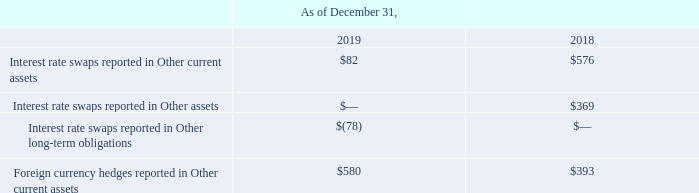NOTES TO CONSOLIDATED FINANCIAL STATEMENTS (in thousands, except for share and per share data)
NOTE 13 — Derivatives
Our earnings and cash flows are subject to fluctuations due to changes in foreign currency exchange rates and interest rates. We selectively use derivative financial instruments including foreign currency forward contracts and interest rate swaps to manage our exposure to these risks.
The use of derivative financial instruments exposes the Company to credit risk, which relates to the risk of nonperformance by a counterparty to the derivative contracts. We manage our credit risk by entering into derivative contracts with only highly rated financial institutions and by using netting agreements.
The effective portion of derivative gains and losses are recorded in accumulated other comprehensive loss until the hedged transaction affects earnings upon settlement, at which time they are reclassified to cost of goods sold or net sales. If it is probable that an anticipated hedged transaction will not occur by the end of the originally specified time period, we reclassify the gains or losses related to that hedge from accumulated other comprehensive loss to other income (expense).
We assess hedge effectiveness qualitatively by verifying that the critical terms of the hedging instrument and the forecasted transaction continue to match, and that there have been no adverse developments that have increased the risk that the counterparty will default. No recognition of ineffectiveness was recorded in our Consolidated Statement of Earnings for the twelve months ended December 31, 2019.
Foreign Currency Hedges
We use forward contracts to mitigate currency risk related to a portion of our forecasted foreign currency revenues and costs. The currency forward contracts are designed as cash flow hedges and are recorded in the Consolidated Balance Sheets at fair value.
We continue to monitor the Company’s overall currency exposure and may elect to add cash flow hedges in the future. At December 31, 2019, we had a net unrealized gain of $655 in accumulated other comprehensive loss, of which $595 is expected to be reclassified to income within the next 12 months. The notional amount of foreign currency forward contracts outstanding was $8,011 at December 31, 2019.
Interest Rate Swaps
We use interest rate swaps to convert a portion of our revolving credit facility's outstanding balance from a variable rate of interest to a fixed rate. As of December 31, 2019, we have agreements to fix interest rates on $50,000 of long-term debt through February 2024. The difference to be paid or received under the terms of the swap agreements will be recognized as an adjustment to interest expense when settled.
These swaps are treated as cash flow hedges and consequently, the changes in fair value are recorded in other comprehensive loss. The estimated net amount of the existing gains or losses that are reported in accumulated other comprehensive loss that are expected to be reclassified into earnings within the next twelve months is approximately $82.
The location and fair values of derivative instruments designated as hedging instruments in the Consolidated Balance Sheets as of December 31, 2019, are shown in the following table:
The Company has elected to net its foreign currency derivative assets and liabilities in the balance sheet in accordance with ASC 210-20 (Balance Sheet, Offsetting). On a gross basis, there were foreign currency derivative assets of $648 and foreign currency derivative liabilities of $68 at December 31, 2019.
Which years does the table provide information for the location and fair values of derivative instruments designated as hedging instruments? 2019, 2018. What were the Interest rate swaps reported in Other assets in 2018?
Answer scale should be: thousand. 369. What was the Foreign currency hedges reported in Other current assets in 2019?
Answer scale should be: thousand. 580. How many years did Foreign currency hedges reported in Other current assets exceed $500 thousand?
Answer scale should be: thousand. 2019
Answer: 1. What was the change in the Interest rate swaps reported in Other current assets between 2018 and 2019?
Answer scale should be: thousand. 82-576
Answer: -494. What was the percentage change in Foreign currency hedges reported in Other current assets between 2018 and 2019?
Answer scale should be: percent. (580-393)/393
Answer: 47.58. 